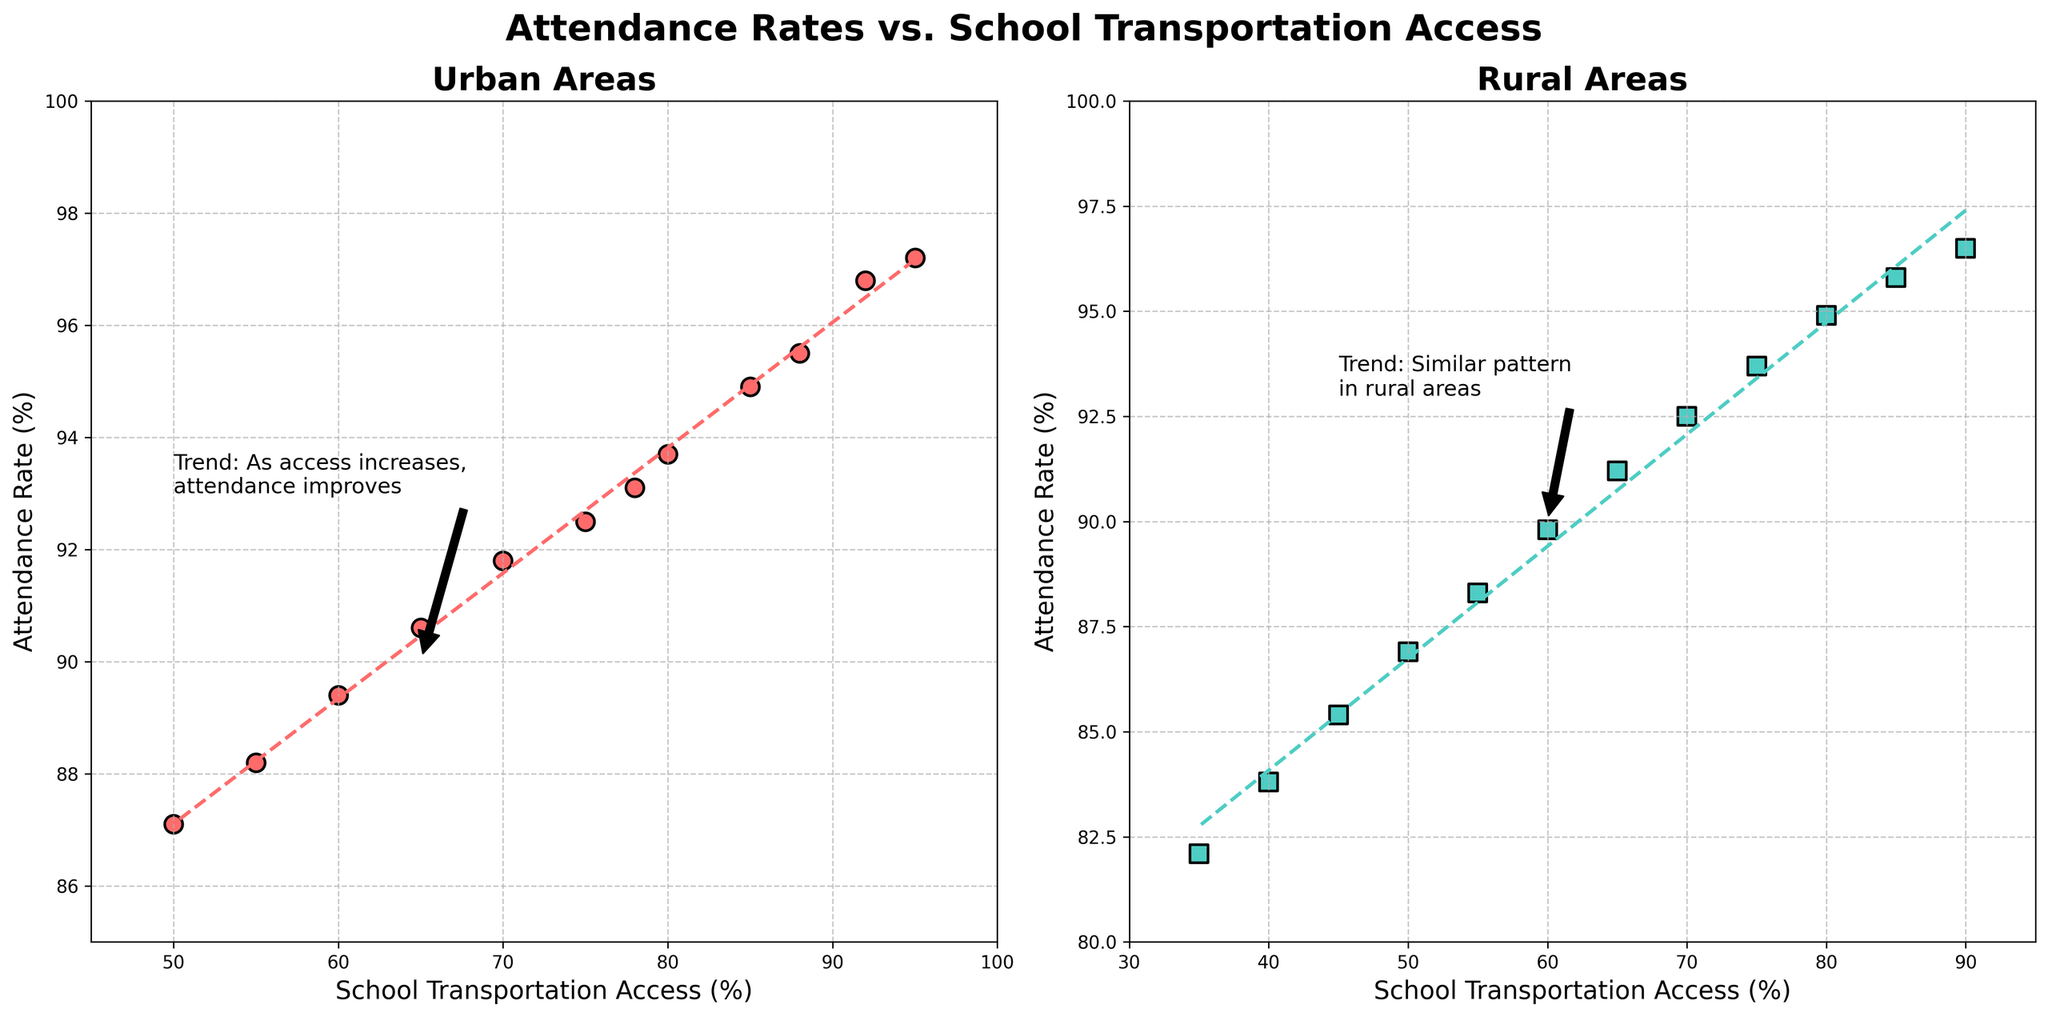What is the trend in urban areas regarding attendance rates and transportation access? The subplot for urban areas shows that as school transportation access increases, the attendance rate also increases. This can be observed from the upward trend of the points and the annotated trend line.
Answer: As transportation access increases, attendance rates improve Which area (urban or rural) has a higher attendance rate when transportation access is at 70%? In the urban subplot, with a 70% transportation access, the attendance rate is around 91.8%. In the rural subplot, for the same transportation access, the attendance rate is around 92.5%.
Answer: Rural What is the overall difference in the y-axis range between the urban and rural subplots? The y-axis for the urban plot ranges from 85 to 100, while the y-axis for the rural plot ranges from 80 to 100. The difference in the y-axis range is 5%.
Answer: 5% How does the slope of the trend line in urban areas compare to that in rural areas? The trend lines in both subplots are upward sloping, indicating a positive relationship between transportation access and attendance rate in both urban and rural areas. However, based on the visual steeper slope, the trend in urban areas appears to be stronger.
Answer: Urban trend is stronger At a transportation access level of 50%, which area has the lower attendance rate? At 50% transportation access, the attendance rate is around 87.1% in urban areas and around 86.9% in rural areas. Thus, rural areas have a lower attendance rate at this access level.
Answer: Rural What is the visual difference in the markers used in both subplots? In the urban subplot, circular markers are used and in the rural subplot, square markers are used. The markers are also differently colored: urban is red, rural is green.
Answer: Urban: circles, red; Rural: squares, green How much higher is the attendance rate at 80% transportation access in urban areas compared to rural areas? At 80% transportation access, the attendance rate is 93.7% in urban areas and 94.9% in rural areas. The difference is 94.9% - 93.7% = 1.2%.
Answer: 1.2% When transportation access is 60%, what is the percentage difference in attendance rates between urban and rural areas? For 60% transportation access, the attendance rate in urban areas is 89.4% while in rural areas it is 89.8%. The percentage difference is (89.8 - 89.4) / 89.4 * 100 = approximately 0.45%.
Answer: Around 0.45% Is there any specific point where both urban and rural areas show the same attendance rate? If so, what is the transportation access at that point? The plots do not show any specific point where the attendance rates align exactly for both urban and rural areas. The trend lines show similar patterns but do not intersect at the same attendance rate.
Answer: No Based on the annotations, what general advice can be inferred for improving attendance rates? The annotations suggest that increasing school transportation access tends to improve attendance rates in both urban and rural areas.
Answer: Improve transportation access 